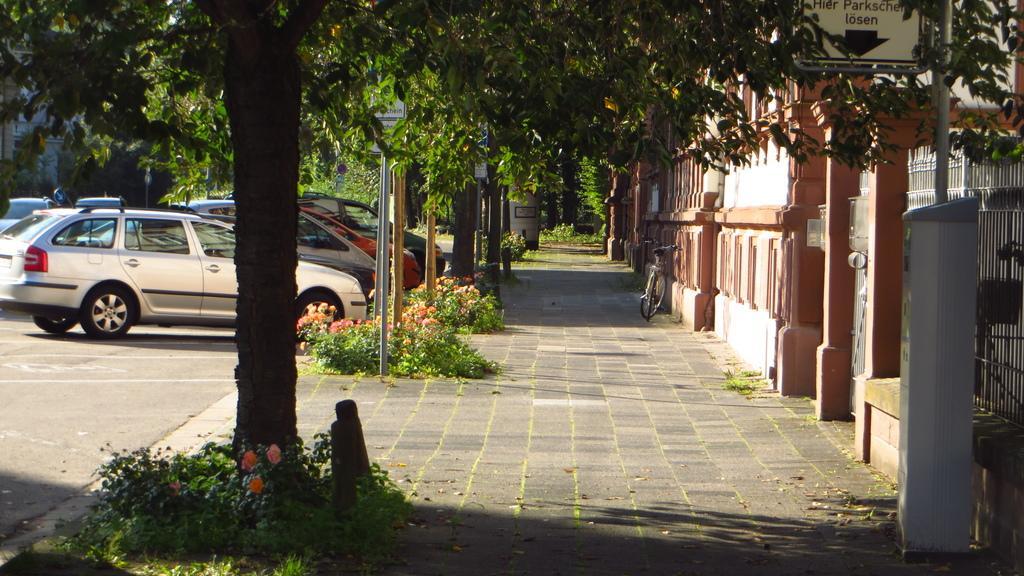Could you give a brief overview of what you see in this image? In this picture we can see many cars which is parked near to the plants, flowers and trees. In the center there is a sign board. On the right there is a bicycle which is parked near to the building. In the bottom left corner we can see the fencing. 